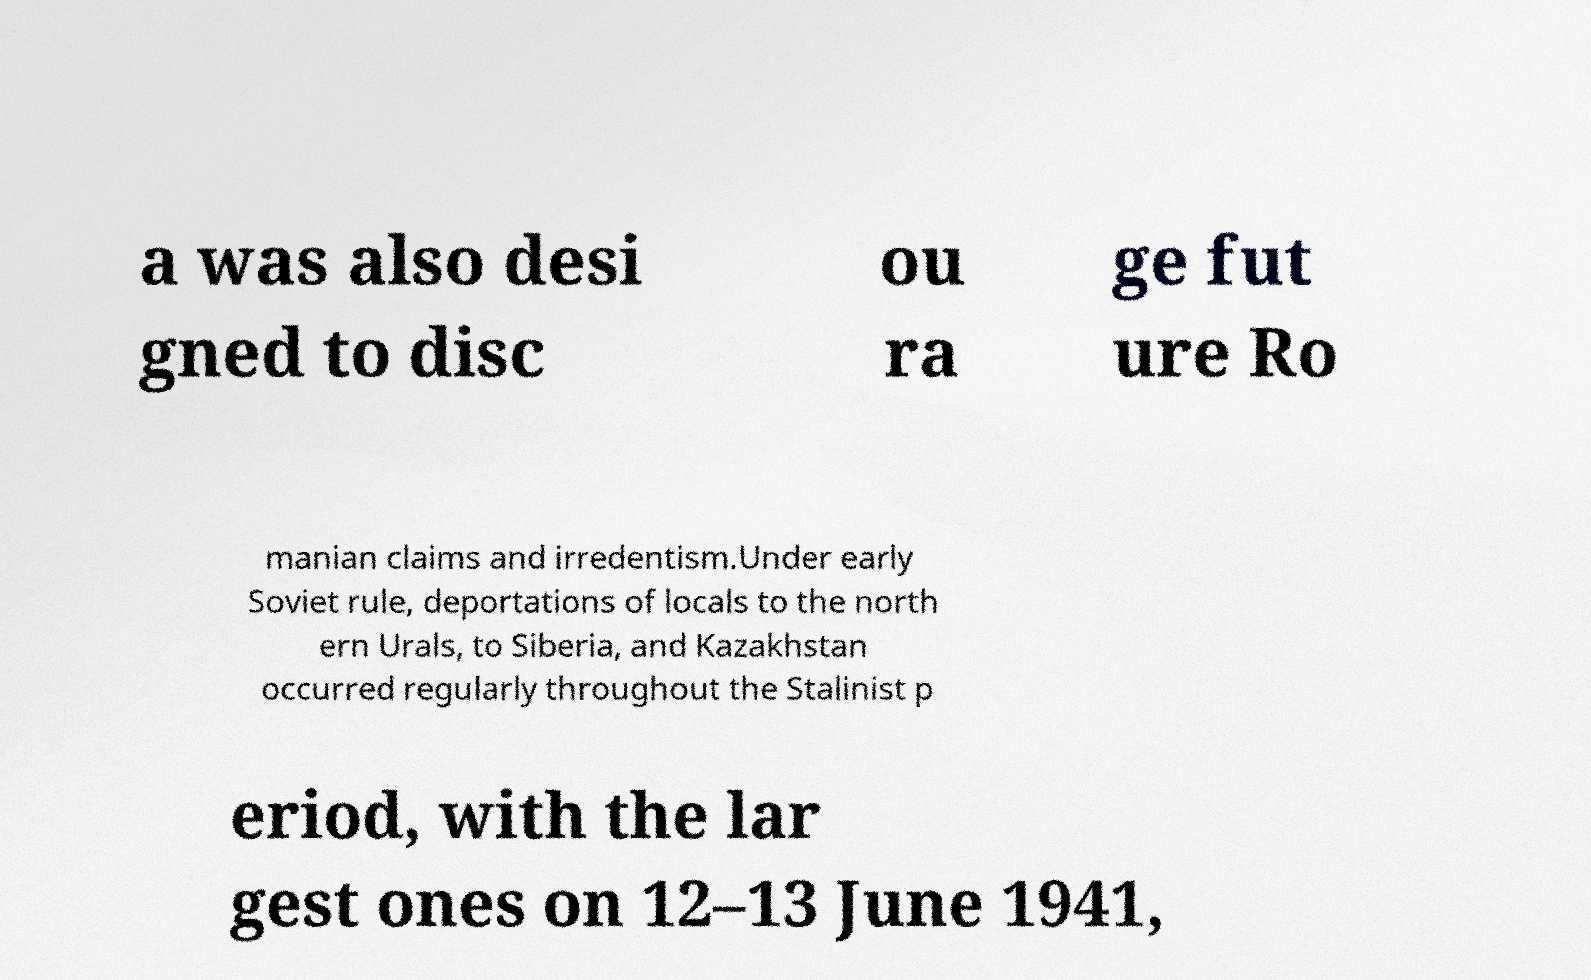Can you read and provide the text displayed in the image?This photo seems to have some interesting text. Can you extract and type it out for me? a was also desi gned to disc ou ra ge fut ure Ro manian claims and irredentism.Under early Soviet rule, deportations of locals to the north ern Urals, to Siberia, and Kazakhstan occurred regularly throughout the Stalinist p eriod, with the lar gest ones on 12–13 June 1941, 